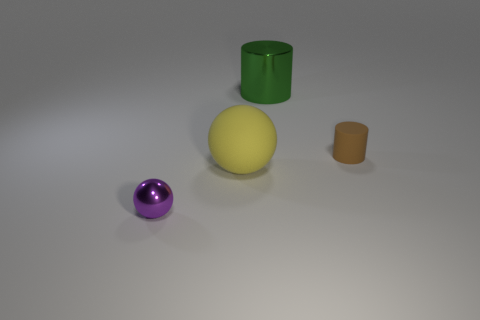Add 3 large green shiny objects. How many objects exist? 7 Subtract all gray cylinders. Subtract all blue balls. How many cylinders are left? 2 Subtract all tiny purple objects. Subtract all small purple shiny things. How many objects are left? 2 Add 4 tiny shiny objects. How many tiny shiny objects are left? 5 Add 3 large matte balls. How many large matte balls exist? 4 Subtract 0 green cubes. How many objects are left? 4 